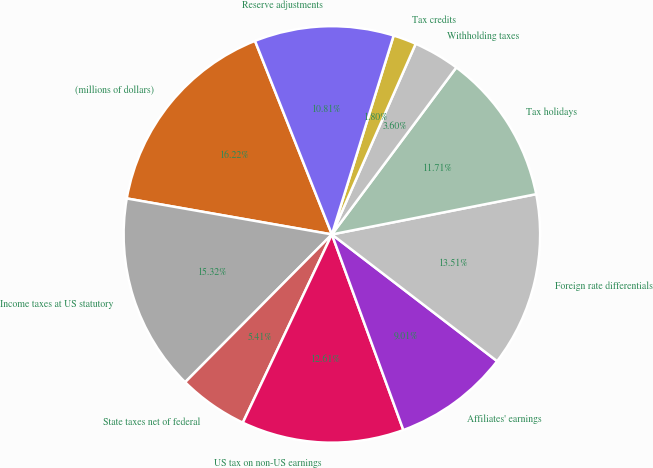Convert chart. <chart><loc_0><loc_0><loc_500><loc_500><pie_chart><fcel>(millions of dollars)<fcel>Income taxes at US statutory<fcel>State taxes net of federal<fcel>US tax on non-US earnings<fcel>Affiliates' earnings<fcel>Foreign rate differentials<fcel>Tax holidays<fcel>Withholding taxes<fcel>Tax credits<fcel>Reserve adjustments<nl><fcel>16.22%<fcel>15.32%<fcel>5.41%<fcel>12.61%<fcel>9.01%<fcel>13.51%<fcel>11.71%<fcel>3.6%<fcel>1.8%<fcel>10.81%<nl></chart> 